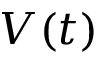Convert formula to latex. <formula><loc_0><loc_0><loc_500><loc_500>V ( t )</formula> 